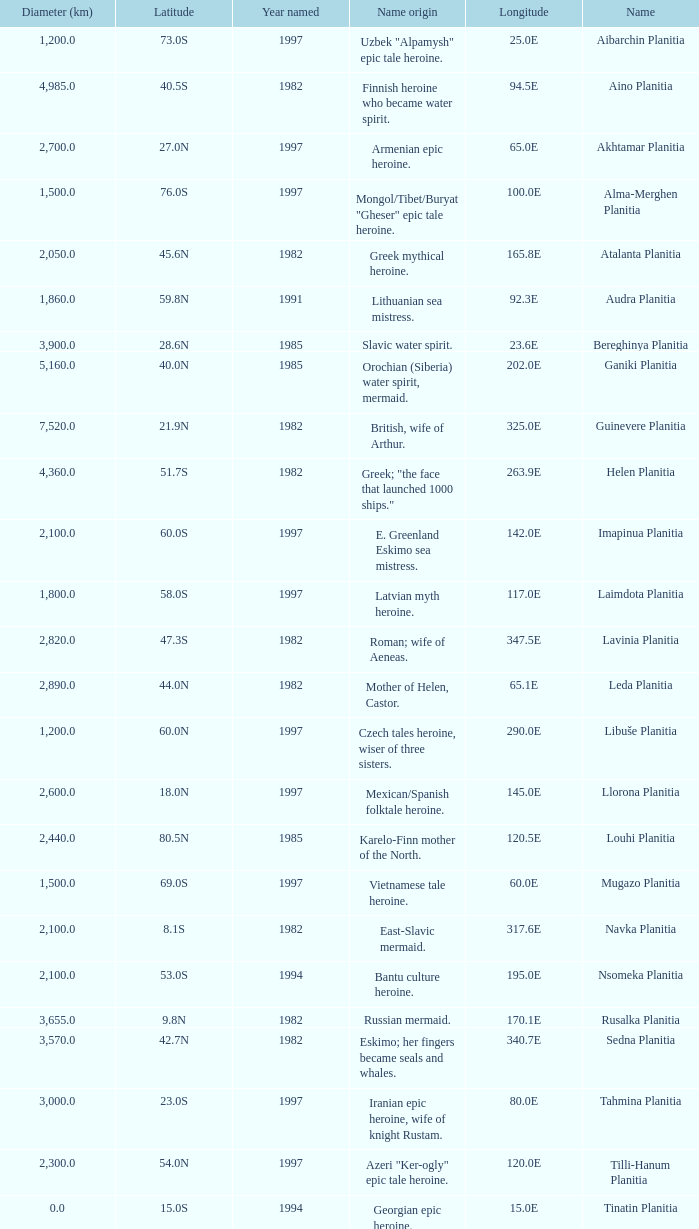What's the name origin of feature of diameter (km) 2,155.0 Karelo-Finn mermaid. Would you be able to parse every entry in this table? {'header': ['Diameter (km)', 'Latitude', 'Year named', 'Name origin', 'Longitude', 'Name'], 'rows': [['1,200.0', '73.0S', '1997', 'Uzbek "Alpamysh" epic tale heroine.', '25.0E', 'Aibarchin Planitia'], ['4,985.0', '40.5S', '1982', 'Finnish heroine who became water spirit.', '94.5E', 'Aino Planitia'], ['2,700.0', '27.0N', '1997', 'Armenian epic heroine.', '65.0E', 'Akhtamar Planitia'], ['1,500.0', '76.0S', '1997', 'Mongol/Tibet/Buryat "Gheser" epic tale heroine.', '100.0E', 'Alma-Merghen Planitia'], ['2,050.0', '45.6N', '1982', 'Greek mythical heroine.', '165.8E', 'Atalanta Planitia'], ['1,860.0', '59.8N', '1991', 'Lithuanian sea mistress.', '92.3E', 'Audra Planitia'], ['3,900.0', '28.6N', '1985', 'Slavic water spirit.', '23.6E', 'Bereghinya Planitia'], ['5,160.0', '40.0N', '1985', 'Orochian (Siberia) water spirit, mermaid.', '202.0E', 'Ganiki Planitia'], ['7,520.0', '21.9N', '1982', 'British, wife of Arthur.', '325.0E', 'Guinevere Planitia'], ['4,360.0', '51.7S', '1982', 'Greek; "the face that launched 1000 ships."', '263.9E', 'Helen Planitia'], ['2,100.0', '60.0S', '1997', 'E. Greenland Eskimo sea mistress.', '142.0E', 'Imapinua Planitia'], ['1,800.0', '58.0S', '1997', 'Latvian myth heroine.', '117.0E', 'Laimdota Planitia'], ['2,820.0', '47.3S', '1982', 'Roman; wife of Aeneas.', '347.5E', 'Lavinia Planitia'], ['2,890.0', '44.0N', '1982', 'Mother of Helen, Castor.', '65.1E', 'Leda Planitia'], ['1,200.0', '60.0N', '1997', 'Czech tales heroine, wiser of three sisters.', '290.0E', 'Libuše Planitia'], ['2,600.0', '18.0N', '1997', 'Mexican/Spanish folktale heroine.', '145.0E', 'Llorona Planitia'], ['2,440.0', '80.5N', '1985', 'Karelo-Finn mother of the North.', '120.5E', 'Louhi Planitia'], ['1,500.0', '69.0S', '1997', 'Vietnamese tale heroine.', '60.0E', 'Mugazo Planitia'], ['2,100.0', '8.1S', '1982', 'East-Slavic mermaid.', '317.6E', 'Navka Planitia'], ['2,100.0', '53.0S', '1994', 'Bantu culture heroine.', '195.0E', 'Nsomeka Planitia'], ['3,655.0', '9.8N', '1982', 'Russian mermaid.', '170.1E', 'Rusalka Planitia'], ['3,570.0', '42.7N', '1982', 'Eskimo; her fingers became seals and whales.', '340.7E', 'Sedna Planitia'], ['3,000.0', '23.0S', '1997', 'Iranian epic heroine, wife of knight Rustam.', '80.0E', 'Tahmina Planitia'], ['2,300.0', '54.0N', '1997', 'Azeri "Ker-ogly" epic tale heroine.', '120.0E', 'Tilli-Hanum Planitia'], ['0.0', '15.0S', '1994', 'Georgian epic heroine.', '15.0E', 'Tinatin Planitia'], ['2,800.0', '13.0N', '1997', 'Lithuanian water nymph, mermaid.', '303.0E', 'Undine Planitia'], ['2,155.0', '45.4N', '1985', 'Karelo-Finn mermaid.', '149.1E', 'Vellamo Planitia']]} 